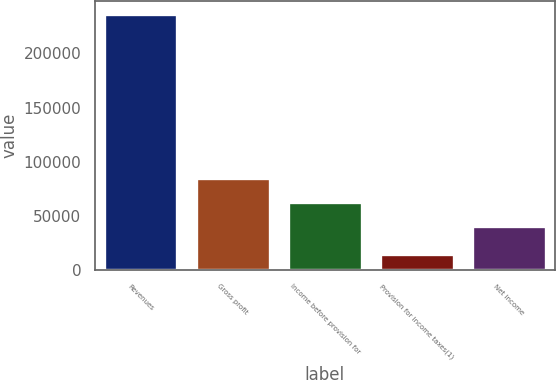Convert chart to OTSL. <chart><loc_0><loc_0><loc_500><loc_500><bar_chart><fcel>Revenues<fcel>Gross profit<fcel>Income before provision for<fcel>Provision for income taxes(1)<fcel>Net income<nl><fcel>236285<fcel>85191.6<fcel>63003.3<fcel>14402<fcel>40815<nl></chart> 